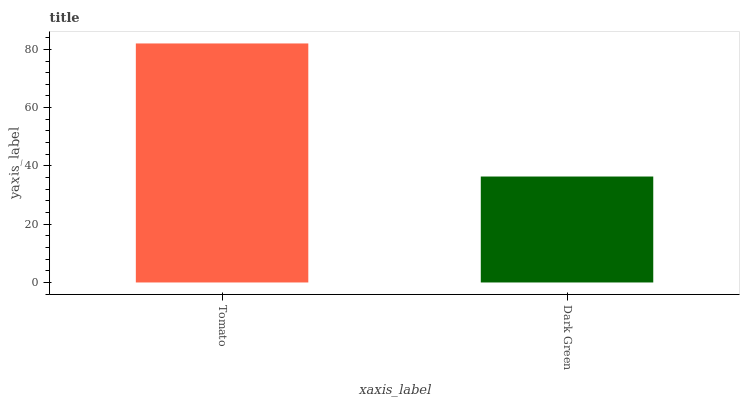Is Dark Green the maximum?
Answer yes or no. No. Is Tomato greater than Dark Green?
Answer yes or no. Yes. Is Dark Green less than Tomato?
Answer yes or no. Yes. Is Dark Green greater than Tomato?
Answer yes or no. No. Is Tomato less than Dark Green?
Answer yes or no. No. Is Tomato the high median?
Answer yes or no. Yes. Is Dark Green the low median?
Answer yes or no. Yes. Is Dark Green the high median?
Answer yes or no. No. Is Tomato the low median?
Answer yes or no. No. 